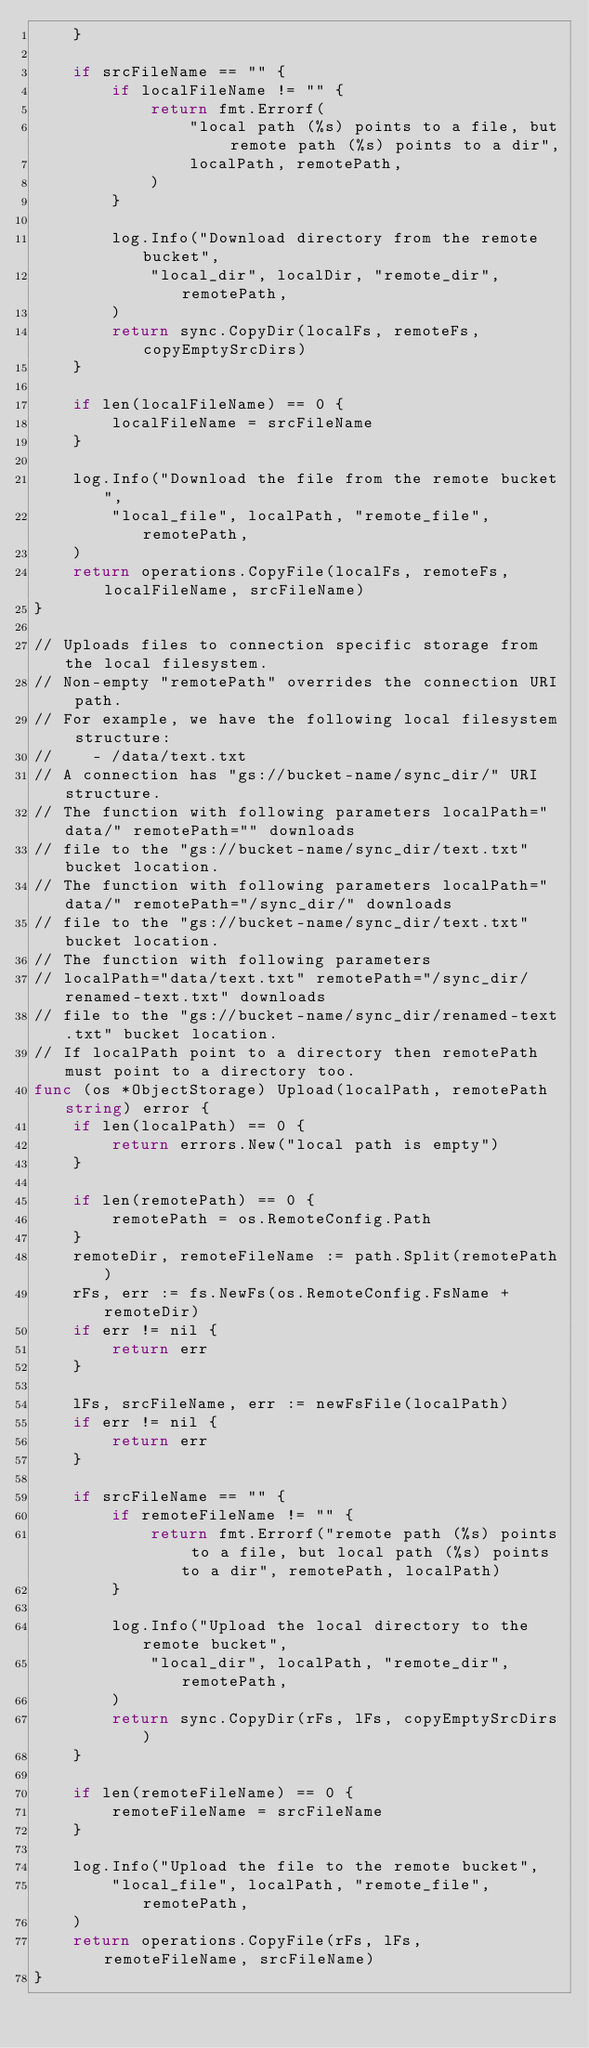<code> <loc_0><loc_0><loc_500><loc_500><_Go_>	}

	if srcFileName == "" {
		if localFileName != "" {
			return fmt.Errorf(
				"local path (%s) points to a file, but remote path (%s) points to a dir",
				localPath, remotePath,
			)
		}

		log.Info("Download directory from the remote bucket",
			"local_dir", localDir, "remote_dir", remotePath,
		)
		return sync.CopyDir(localFs, remoteFs, copyEmptySrcDirs)
	}

	if len(localFileName) == 0 {
		localFileName = srcFileName
	}

	log.Info("Download the file from the remote bucket",
		"local_file", localPath, "remote_file", remotePath,
	)
	return operations.CopyFile(localFs, remoteFs, localFileName, srcFileName)
}

// Uploads files to connection specific storage from the local filesystem.
// Non-empty "remotePath" overrides the connection URI path.
// For example, we have the following local filesystem structure:
//    - /data/text.txt
// A connection has "gs://bucket-name/sync_dir/" URI structure.
// The function with following parameters localPath="data/" remotePath="" downloads
// file to the "gs://bucket-name/sync_dir/text.txt" bucket location.
// The function with following parameters localPath="data/" remotePath="/sync_dir/" downloads
// file to the "gs://bucket-name/sync_dir/text.txt" bucket location.
// The function with following parameters
// localPath="data/text.txt" remotePath="/sync_dir/renamed-text.txt" downloads
// file to the "gs://bucket-name/sync_dir/renamed-text.txt" bucket location.
// If localPath point to a directory then remotePath must point to a directory too.
func (os *ObjectStorage) Upload(localPath, remotePath string) error {
	if len(localPath) == 0 {
		return errors.New("local path is empty")
	}

	if len(remotePath) == 0 {
		remotePath = os.RemoteConfig.Path
	}
	remoteDir, remoteFileName := path.Split(remotePath)
	rFs, err := fs.NewFs(os.RemoteConfig.FsName + remoteDir)
	if err != nil {
		return err
	}

	lFs, srcFileName, err := newFsFile(localPath)
	if err != nil {
		return err
	}

	if srcFileName == "" {
		if remoteFileName != "" {
			return fmt.Errorf("remote path (%s) points to a file, but local path (%s) points to a dir", remotePath, localPath)
		}

		log.Info("Upload the local directory to the remote bucket",
			"local_dir", localPath, "remote_dir", remotePath,
		)
		return sync.CopyDir(rFs, lFs, copyEmptySrcDirs)
	}

	if len(remoteFileName) == 0 {
		remoteFileName = srcFileName
	}

	log.Info("Upload the file to the remote bucket",
		"local_file", localPath, "remote_file", remotePath,
	)
	return operations.CopyFile(rFs, lFs, remoteFileName, srcFileName)
}
</code> 